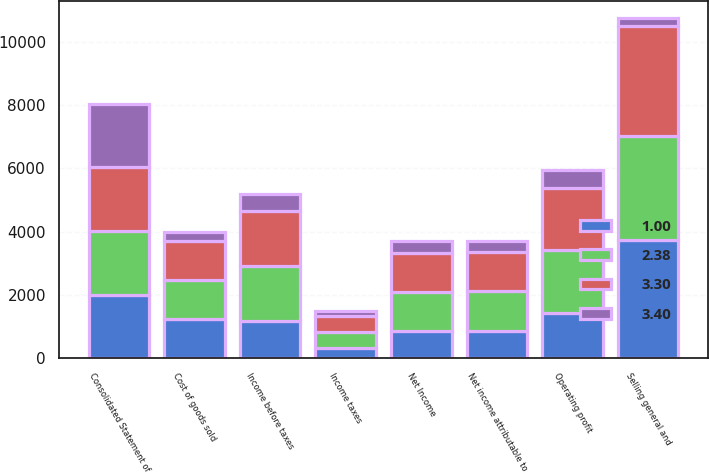Convert chart. <chart><loc_0><loc_0><loc_500><loc_500><stacked_bar_chart><ecel><fcel>Consolidated Statement of<fcel>Cost of goods sold<fcel>Selling general and<fcel>Operating profit<fcel>Income before taxes<fcel>Income taxes<fcel>Net Income<fcel>Net income attributable to<nl><fcel>3.3<fcel>2011<fcel>1231<fcel>3472<fcel>1976<fcel>1732<fcel>503<fcel>1229<fcel>1231<nl><fcel>1<fcel>2011<fcel>1231<fcel>3725<fcel>1427<fcel>1184<fcel>320<fcel>864<fcel>866<nl><fcel>3.4<fcel>2011<fcel>296<fcel>253<fcel>549<fcel>548<fcel>183<fcel>365<fcel>365<nl><fcel>2.38<fcel>2010<fcel>1231<fcel>3299<fcel>1990<fcel>1742<fcel>502<fcel>1240<fcel>1247<nl></chart> 